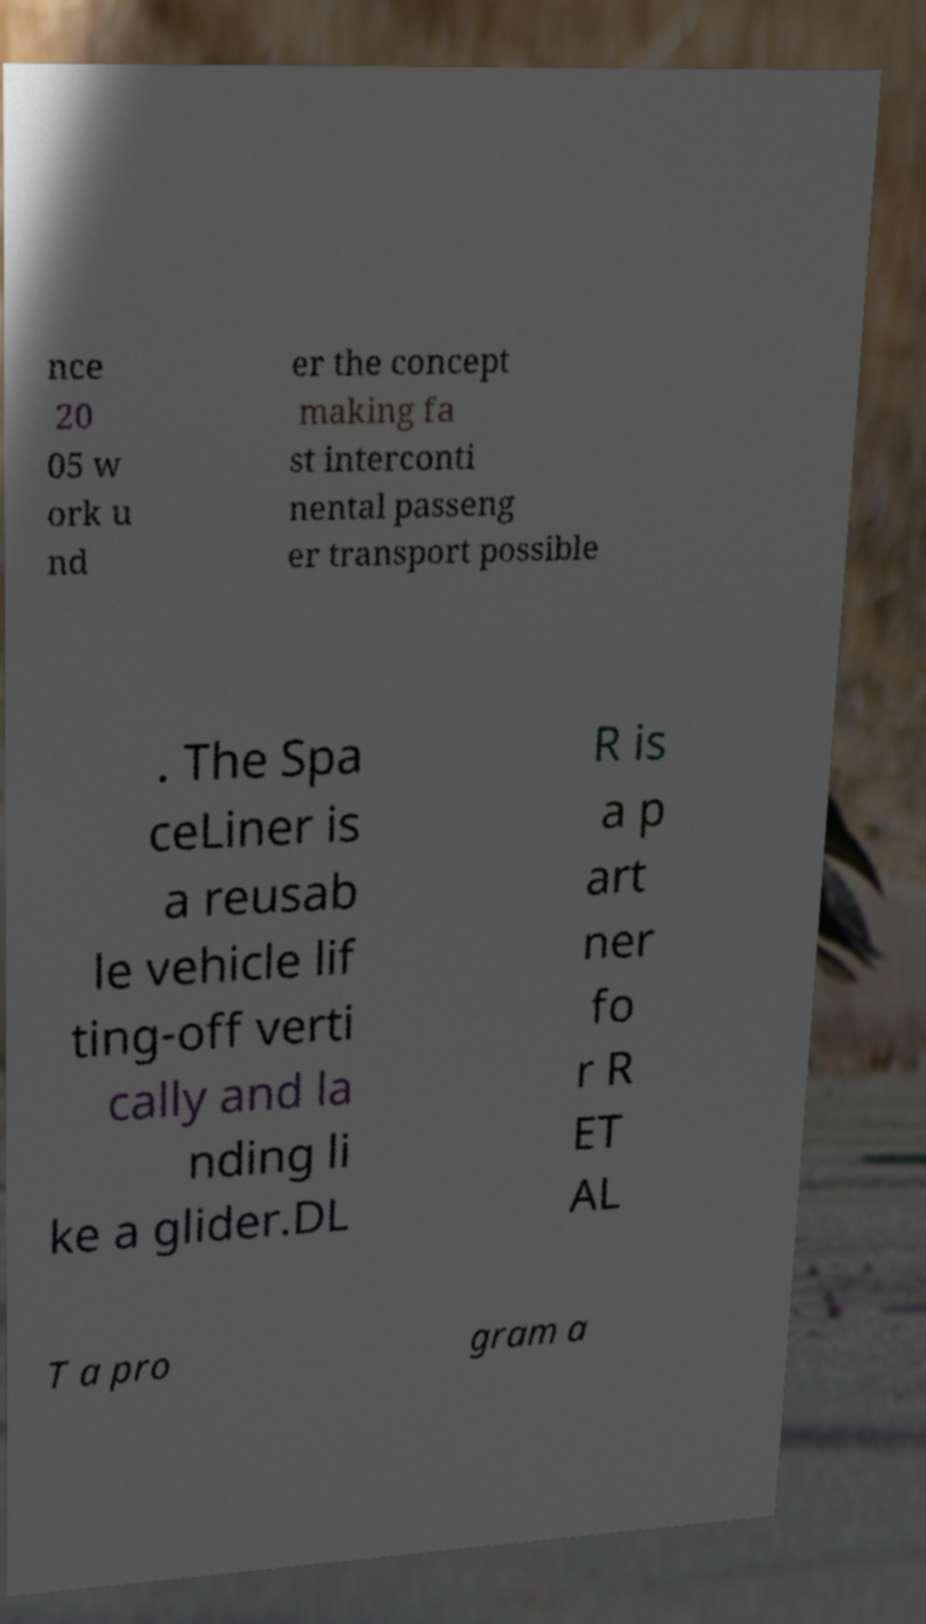For documentation purposes, I need the text within this image transcribed. Could you provide that? nce 20 05 w ork u nd er the concept making fa st interconti nental passeng er transport possible . The Spa ceLiner is a reusab le vehicle lif ting-off verti cally and la nding li ke a glider.DL R is a p art ner fo r R ET AL T a pro gram a 